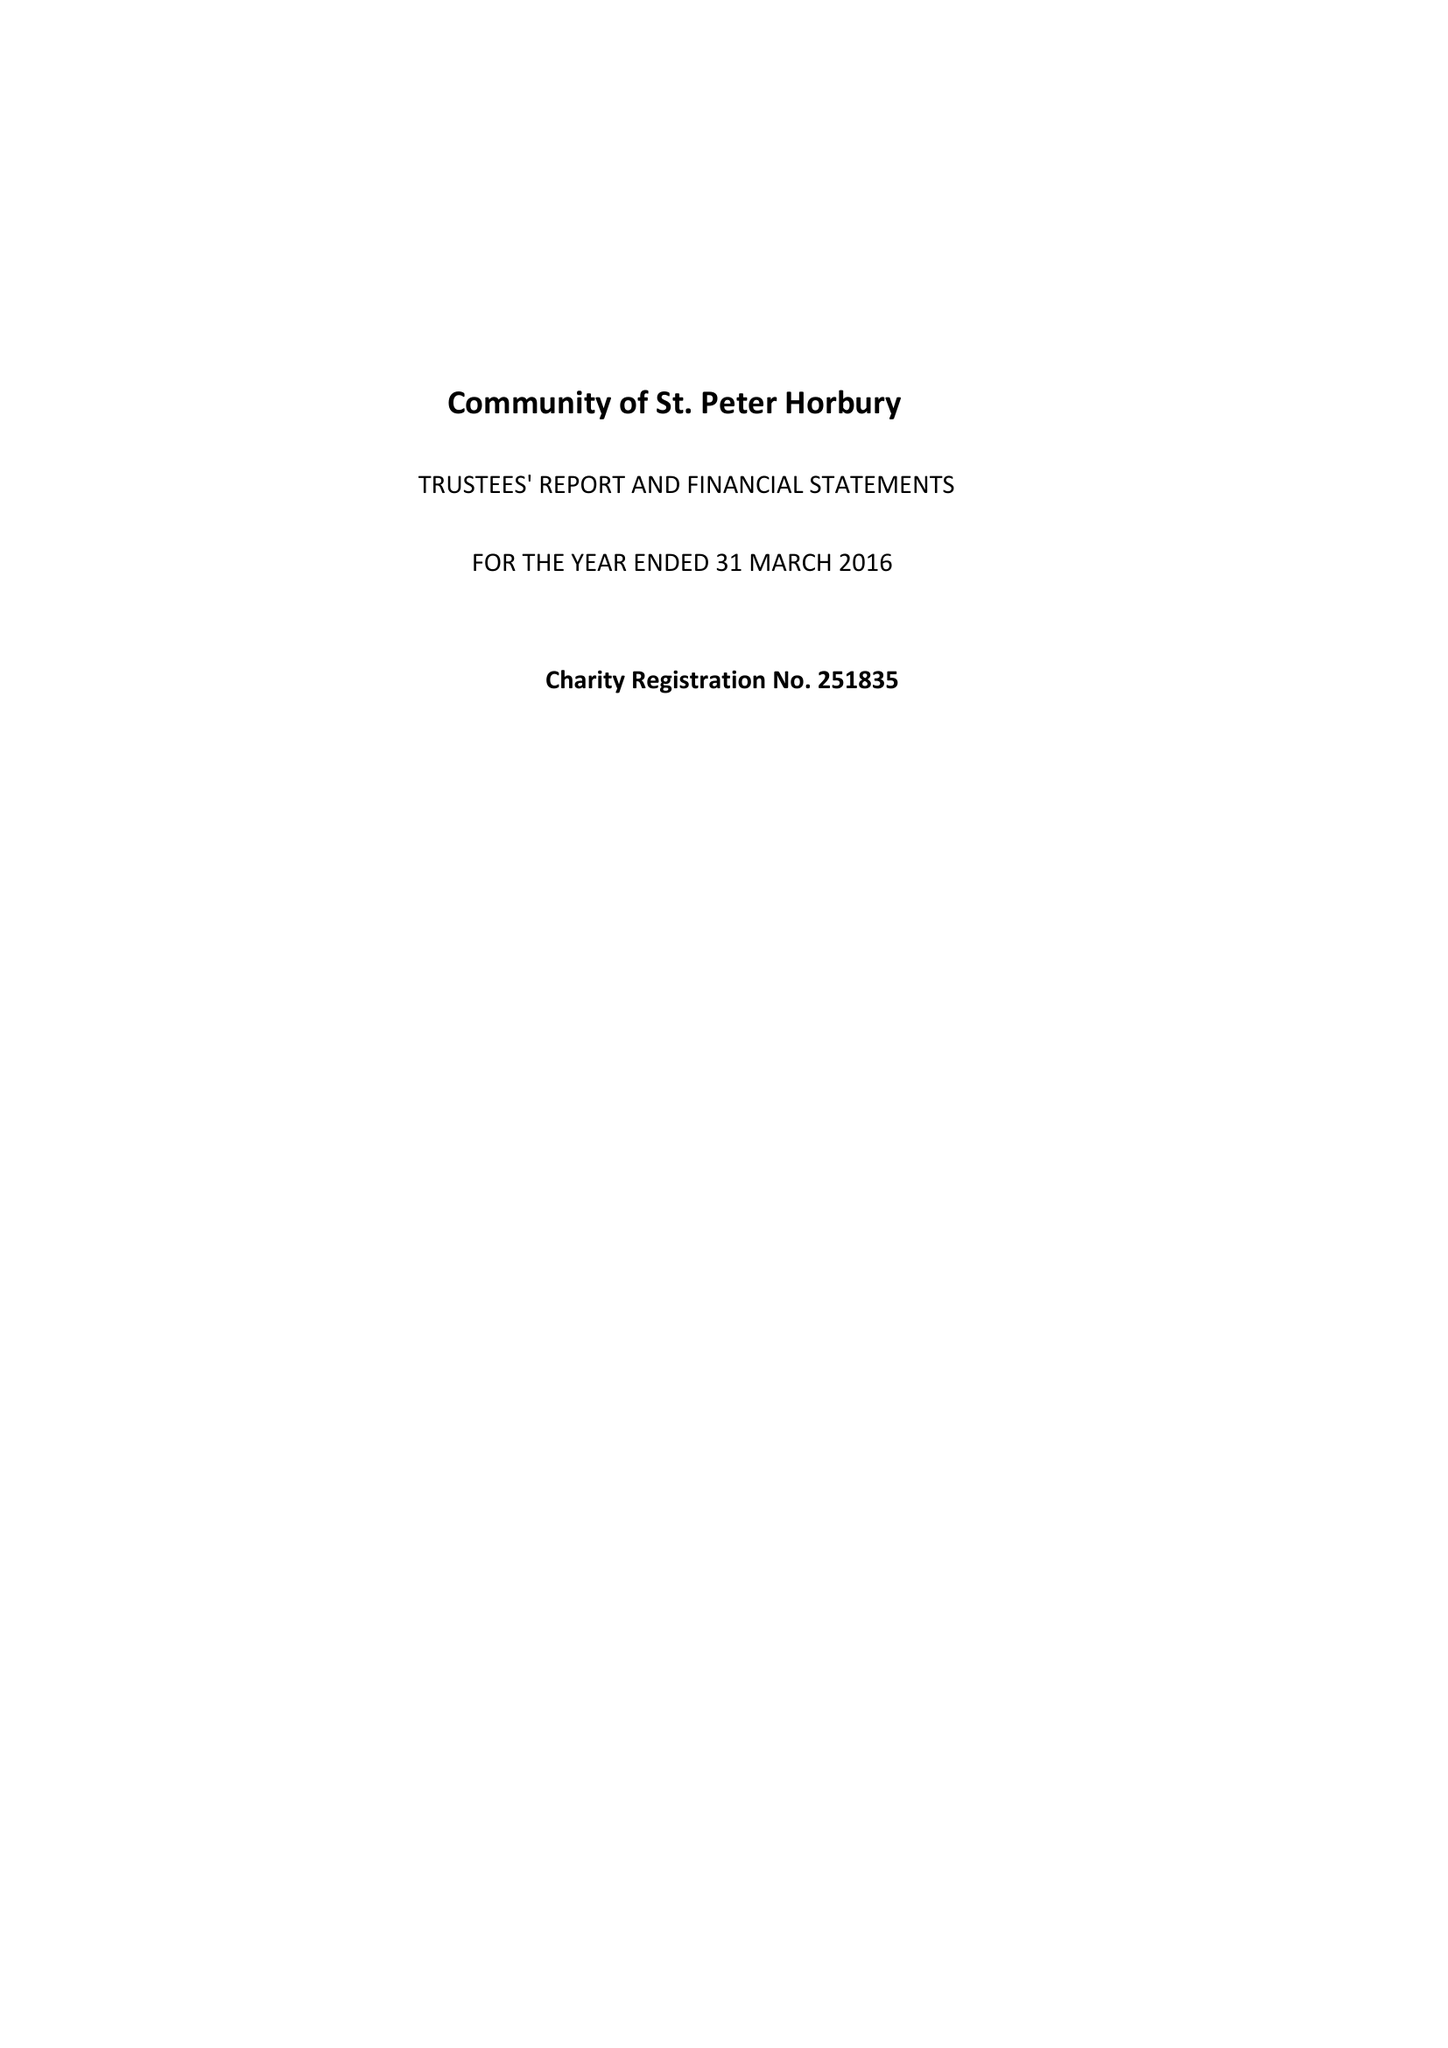What is the value for the address__post_town?
Answer the question using a single word or phrase. WAKEFIELD 